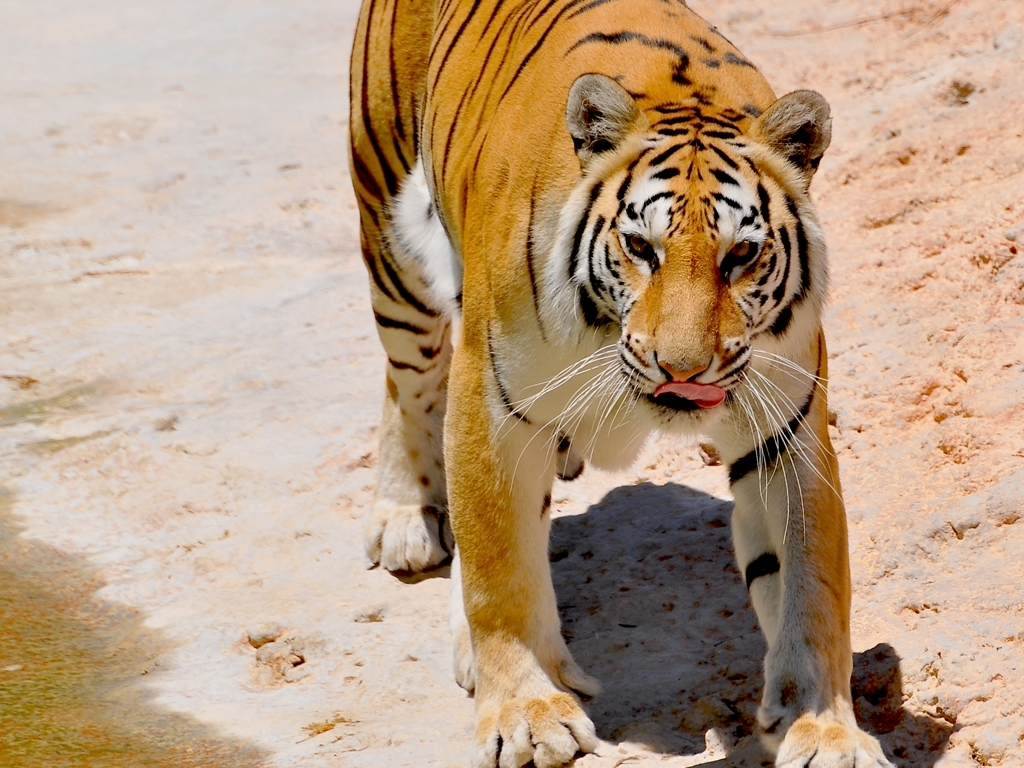What can you tell me about the tiger's habitat based on this image? This tiger appears to be in a dry, perhaps sandy environment, as you can see from the ground it's walking on. There's no lush vegetation in sight, which might suggest a zoo or sanctuary setting, especially since the surroundings do not resemble a dense, forested habitat typical for tigers in the wild. 